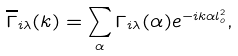<formula> <loc_0><loc_0><loc_500><loc_500>\overline { \Gamma } _ { i \lambda } ( k ) = \sum _ { \alpha } \Gamma _ { i \lambda } ( \alpha ) e ^ { - i k \alpha l _ { o } ^ { 2 } } ,</formula> 